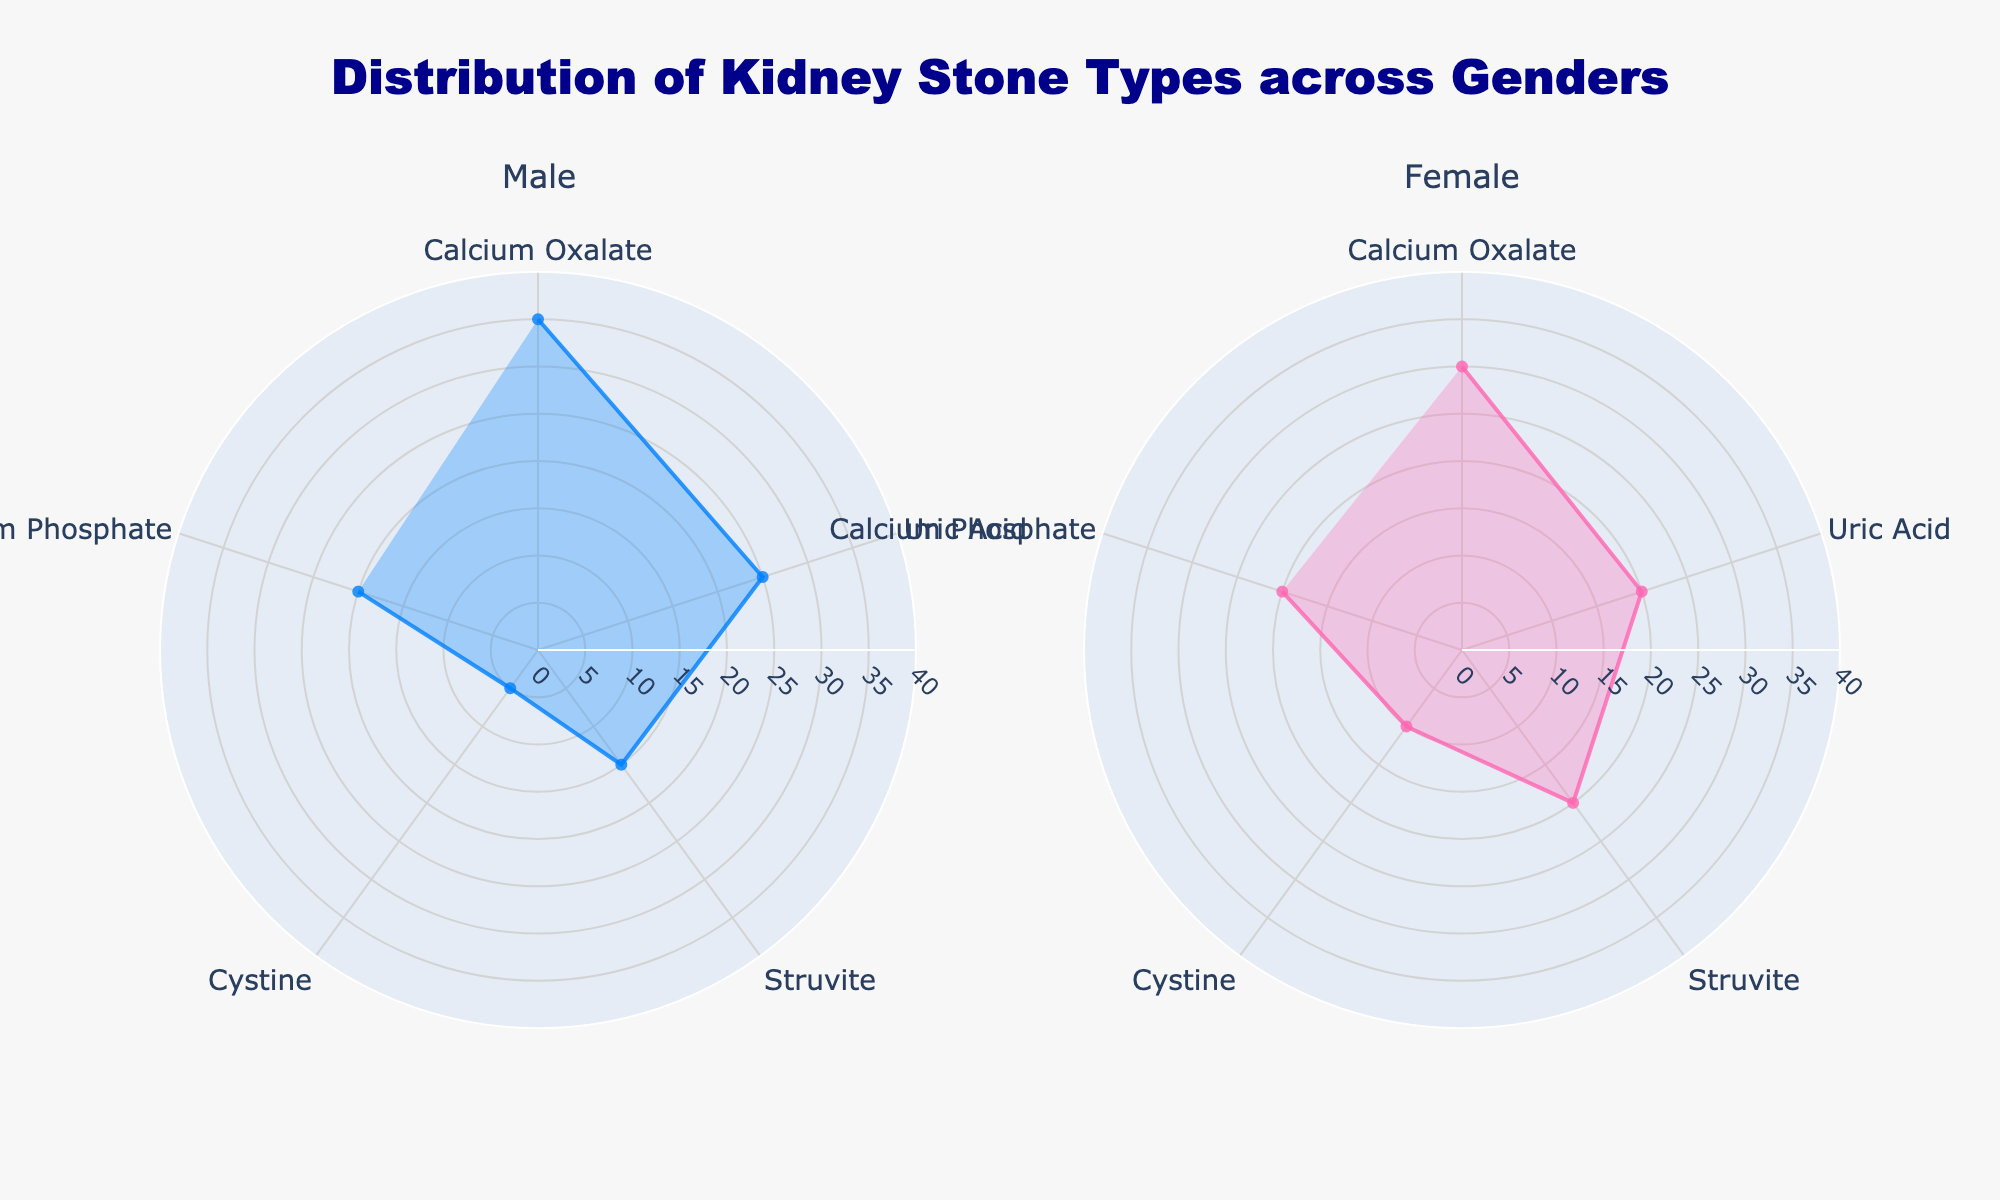Which Kidney Stone Type has the highest percentage for males? First, look at the male subplot. Observe the percentages for each kidney stone type. Identify the type with the highest value. Calcium Oxalate has the highest percentage at 35%.
Answer: Calcium Oxalate Which gender has a higher percentage of Struvite stones? Compare the percentage of Struvite stones between the male and female subplots. Males have 15%, while females have 20%. Therefore, females have a higher percentage.
Answer: Female What's the difference in percentage of Uric Acid stones between males and females? First, note the Uric Acid percentages for both genders. Males have 25% and females have 20%. Subtract the female percentage from the male percentage: 25% - 20% = 5%.
Answer: 5% What's the combined percentage of Cystine and Calcium Phosphate stones for females? Identify the percentages for Cystine (10%) and Calcium Phosphate (20%) in the female subplot. Add these percentages together: 10% + 20% = 30%.
Answer: 30% Do males or females have a more uniform distribution of kidney stone types? Compare the range and variation of percentages for each gender. Males have a wider range of percentages (5% to 35%) compared to females (10% to 30%). Therefore, females have a more uniform distribution.
Answer: Females Which kidney stone type has the lowest percentage among males? Observe the percentages for all kidney stone types in the male subplot. The lowest percentage is for Cystine, at 5%.
Answer: Cystine Which gender has the most similar percentages for all kidney stone types? Compare the range of percentages for each gender's kidney stone types. Females have more similar percentages, ranging from 10% to 30%, compared to males, whose percentages range from 5% to 35%.
Answer: Females For which kidney stone type is the percentage exactly the same for both genders? Check both subplots for any kidney stone type where the percentages are identical. Calcium Phosphate has the same percentage of 20% for both genders.
Answer: Calcium Phosphate Which kidney stone type has a higher percentage in males than in females? Compare the percentages for each kidney stone type between genders. Calcium Oxalate and Uric Acid both have higher percentages in males.
Answer: Calcium Oxalate and Uric Acid 